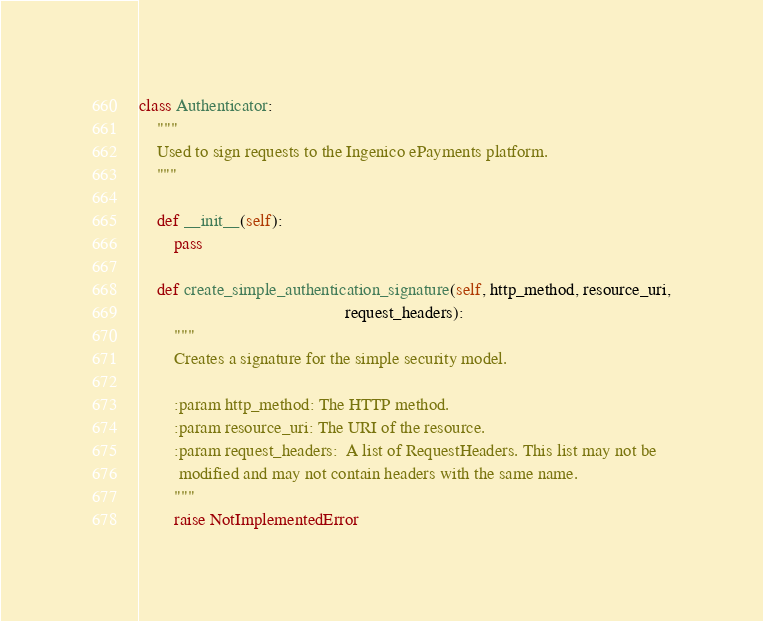Convert code to text. <code><loc_0><loc_0><loc_500><loc_500><_Python_>class Authenticator:
    """
    Used to sign requests to the Ingenico ePayments platform.
    """

    def __init__(self):
        pass

    def create_simple_authentication_signature(self, http_method, resource_uri,
                                               request_headers):
        """
        Creates a signature for the simple security model.

        :param http_method: The HTTP method.
        :param resource_uri: The URI of the resource.
        :param request_headers:  A list of RequestHeaders. This list may not be
         modified and may not contain headers with the same name.
        """
        raise NotImplementedError
</code> 